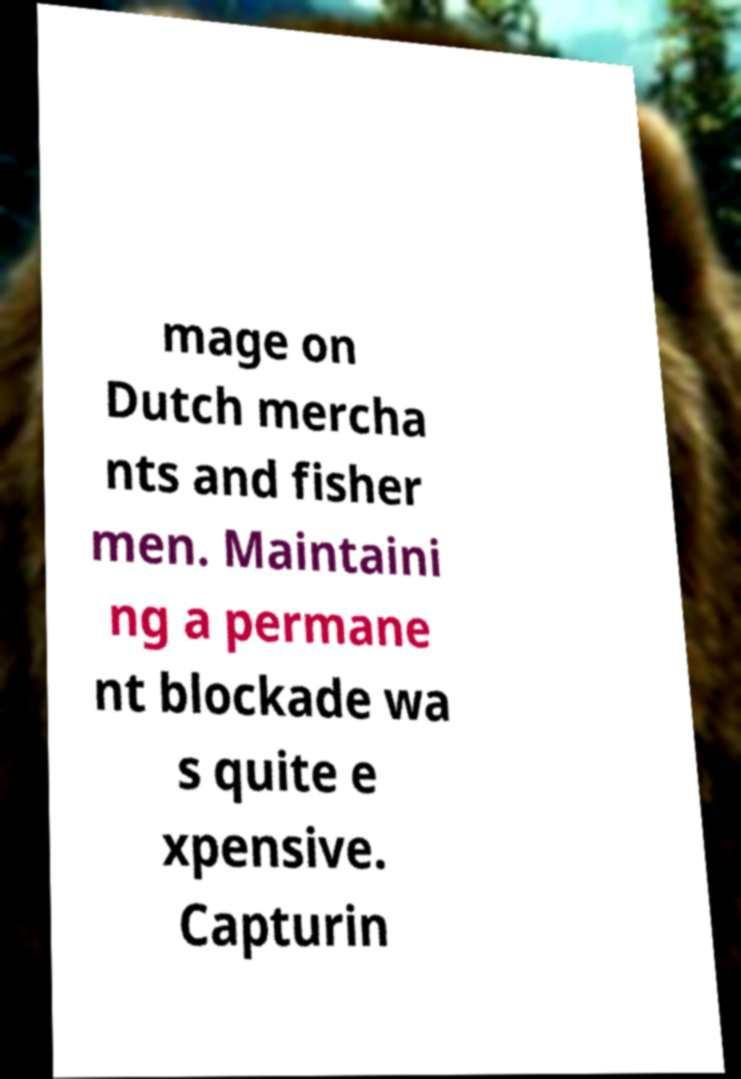I need the written content from this picture converted into text. Can you do that? mage on Dutch mercha nts and fisher men. Maintaini ng a permane nt blockade wa s quite e xpensive. Capturin 